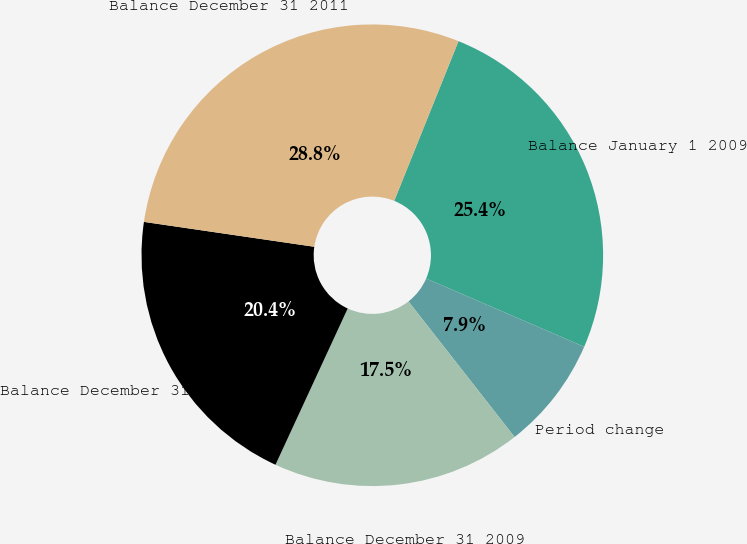<chart> <loc_0><loc_0><loc_500><loc_500><pie_chart><fcel>Balance January 1 2009<fcel>Period change<fcel>Balance December 31 2009<fcel>Balance December 31 2010<fcel>Balance December 31 2011<nl><fcel>25.4%<fcel>7.94%<fcel>17.46%<fcel>20.42%<fcel>28.78%<nl></chart> 